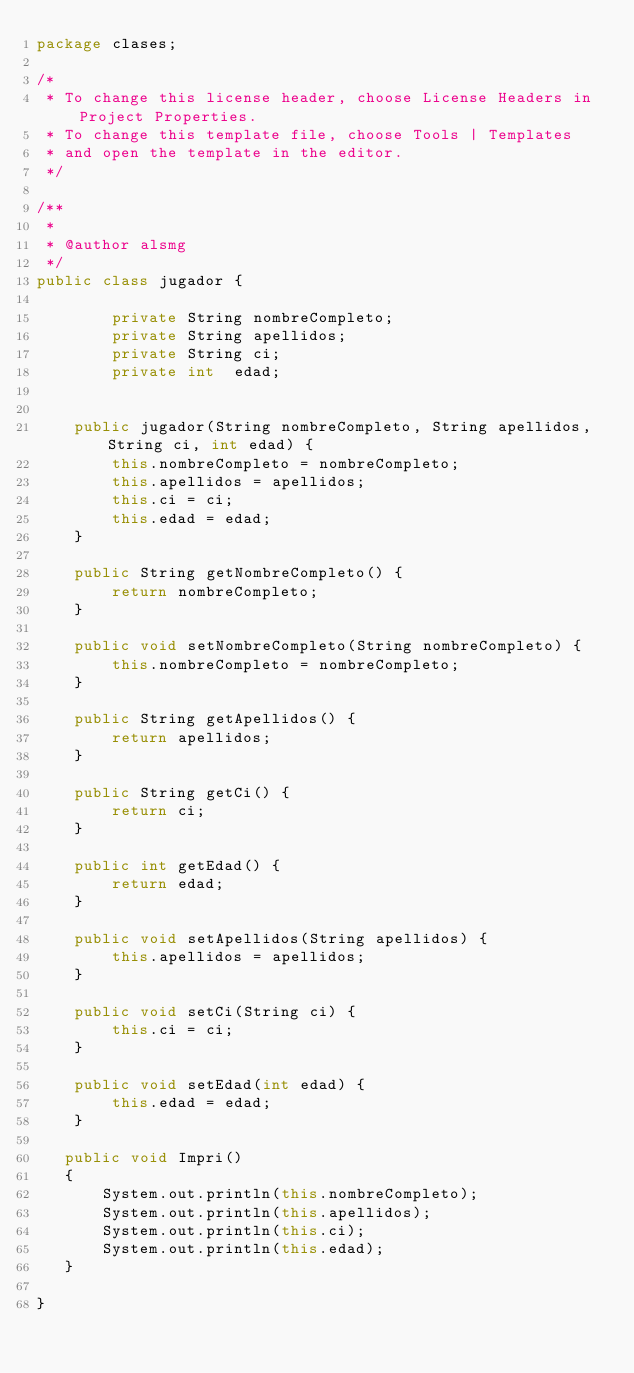Convert code to text. <code><loc_0><loc_0><loc_500><loc_500><_Java_>package clases;

/*
 * To change this license header, choose License Headers in Project Properties.
 * To change this template file, choose Tools | Templates
 * and open the template in the editor.
 */

/**
 *
 * @author alsmg
 */
public class jugador {
  
        private String nombreCompleto;
        private String apellidos;
        private String ci;
        private int  edad;
  

    public jugador(String nombreCompleto, String apellidos, String ci, int edad) {
        this.nombreCompleto = nombreCompleto;
        this.apellidos = apellidos;
        this.ci = ci;
        this.edad = edad;
    }

    public String getNombreCompleto() {
        return nombreCompleto;
    }

    public void setNombreCompleto(String nombreCompleto) {
        this.nombreCompleto = nombreCompleto;
    }

    public String getApellidos() {
        return apellidos;
    }

    public String getCi() {
        return ci;
    }

    public int getEdad() {
        return edad;
    }

    public void setApellidos(String apellidos) {
        this.apellidos = apellidos;
    }

    public void setCi(String ci) {
        this.ci = ci;
    }

    public void setEdad(int edad) {
        this.edad = edad;
    }
  
   public void Impri()
   {
       System.out.println(this.nombreCompleto);
       System.out.println(this.apellidos);
       System.out.println(this.ci);
       System.out.println(this.edad);
   }
        
}
</code> 